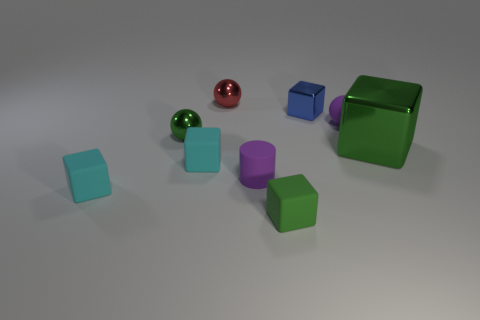There is a thing that is both behind the purple rubber sphere and on the right side of the purple matte cylinder; what is its material?
Offer a terse response. Metal. There is a large green thing that is the same material as the tiny blue object; what shape is it?
Keep it short and to the point. Cube. There is a green object that is the same material as the cylinder; what size is it?
Your response must be concise. Small. What shape is the metallic thing that is both in front of the tiny purple ball and on the right side of the red metallic thing?
Ensure brevity in your answer.  Cube. There is a green block in front of the purple thing left of the purple rubber sphere; how big is it?
Ensure brevity in your answer.  Small. How many other objects are the same color as the big metallic cube?
Your answer should be compact. 2. What material is the blue block?
Ensure brevity in your answer.  Metal. Are there any big green spheres?
Provide a short and direct response. No. Is the number of small red things behind the tiny red thing the same as the number of big blue objects?
Provide a short and direct response. Yes. How many big objects are either green objects or green metal cubes?
Your answer should be very brief. 1. 